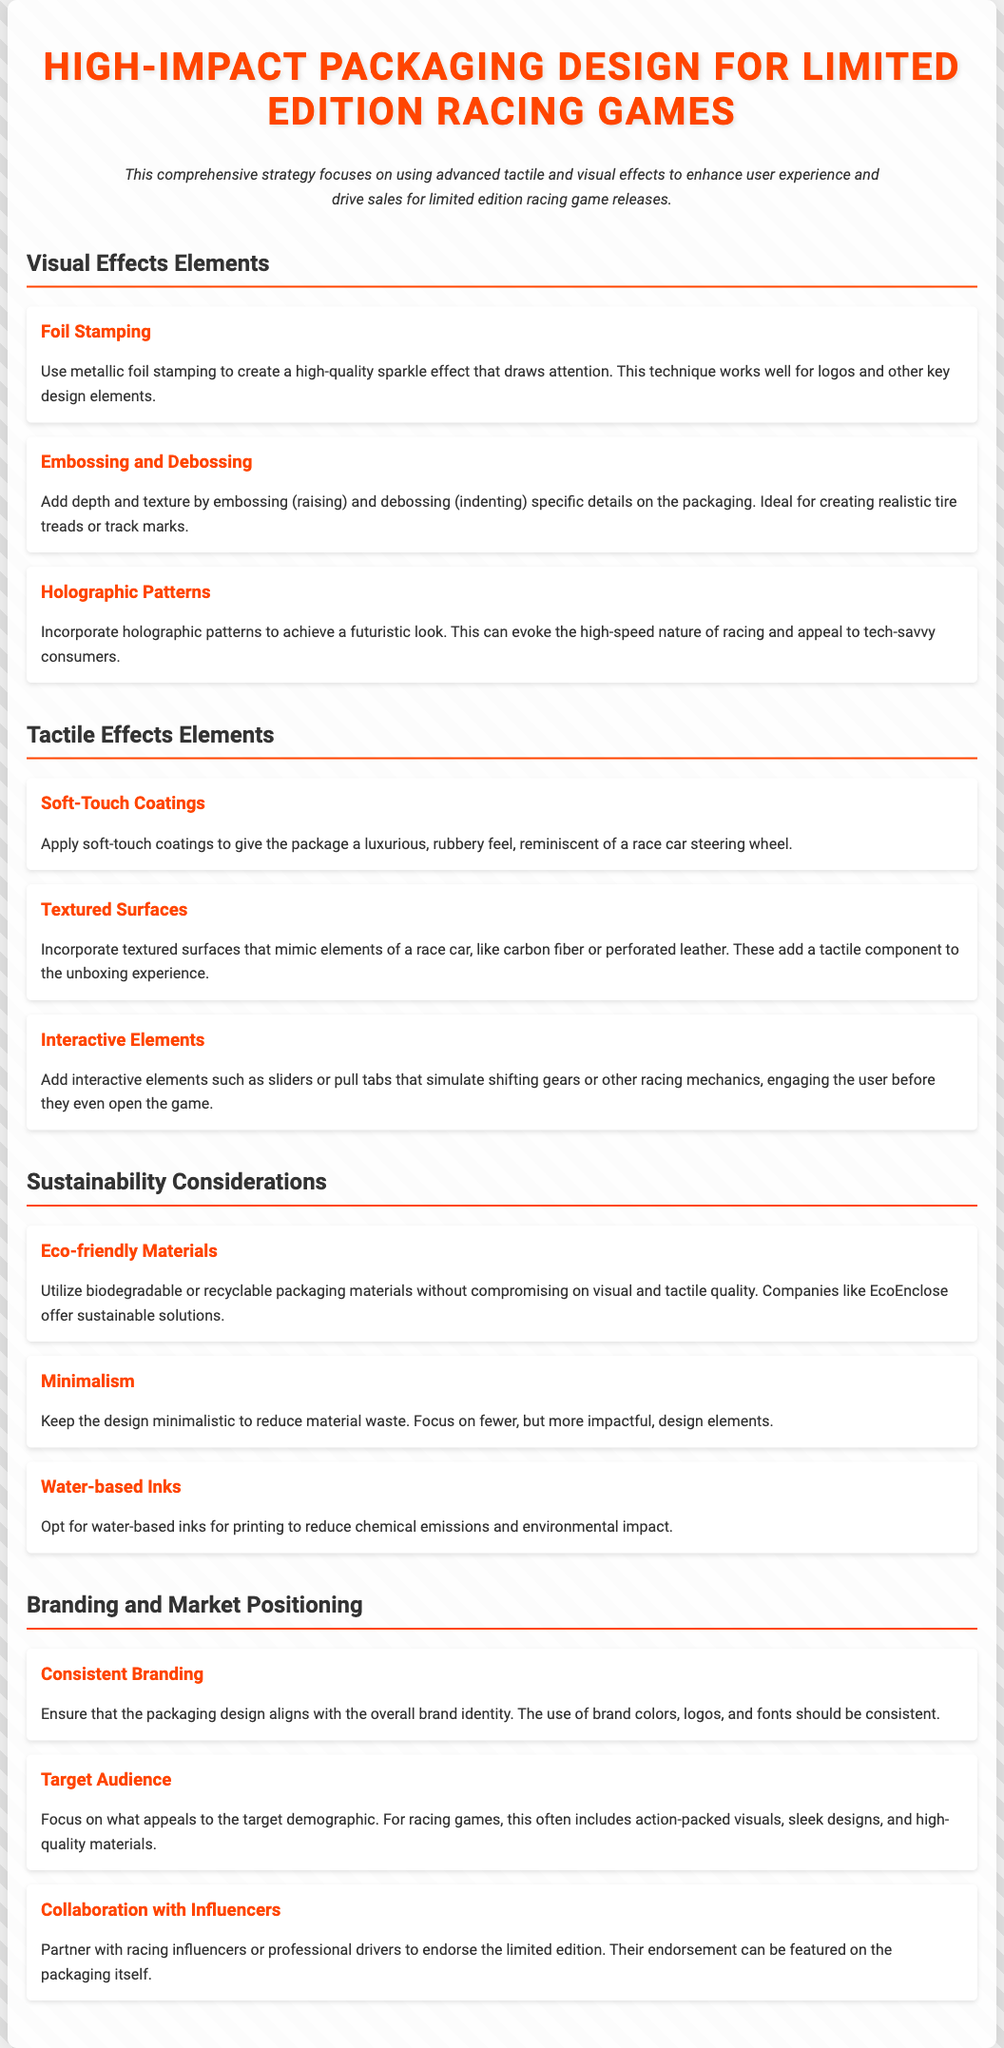what is the title of the document? The title is stated at the top of the document, indicating the subject of the content.
Answer: High-Impact Packaging Design for Limited Edition Racing Games what visual element is used to create a sparkle effect? The document describes specific visual effects, one of which is foil stamping that creates a sparkle effect.
Answer: Foil Stamping what tactile effect mimics a race car steering wheel? The document mentions specific tactile elements, one of which is soft-touch coatings that provide a rubbery feel.
Answer: Soft-Touch Coatings which sustainable packaging material is recommended? There is mention of eco-friendly materials that should be utilized, specifically those that are biodegradable or recyclable.
Answer: Eco-friendly Materials what is the purpose of collaborating with influencers? The document states that collaborating with influencers can help endorse limited editions and that this can be featured on the packaging.
Answer: Endorsement what is a key consideration for branding? The document emphasizes the importance of consistent branding in aligning packaging design with brand identity.
Answer: Consistent Branding how many sections are there in the document? By counting the titled sections present in the document, the total number of sections can be determined.
Answer: Four what type of coating gives a luxurious feel? The document describes soft-touch coatings as providing a luxurious feel similar to that of a race car steering wheel.
Answer: Soft-Touch Coatings what printing method is suggested to reduce environmental impact? The document provides information on printing methods, highlighting the use of water-based inks as a suggestion to reduce chemical emissions.
Answer: Water-based Inks 